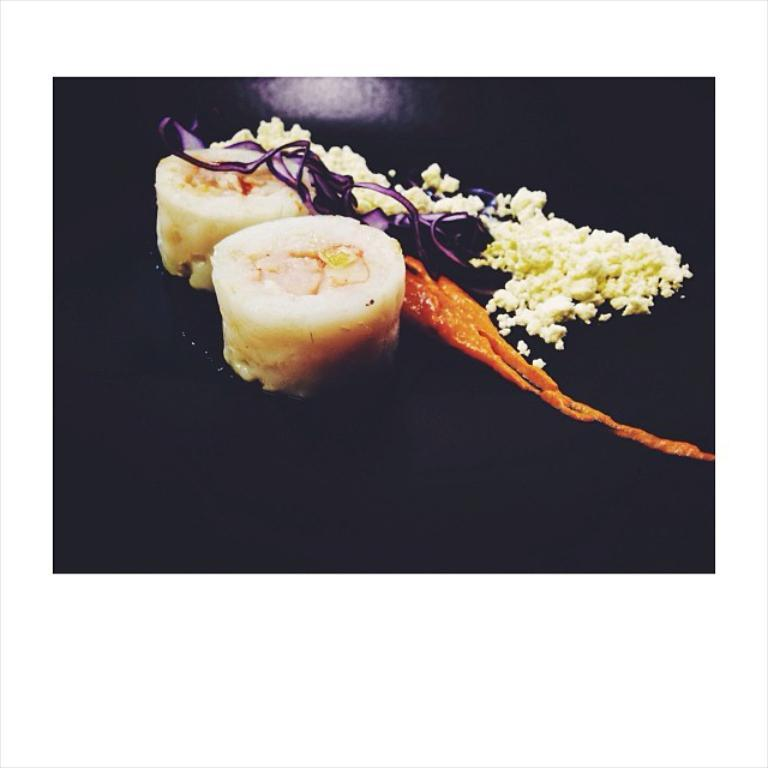What types of items can be seen in the image? There are food items in the image. Can you describe the appearance of the image's edges? The corners of the image are black. How many cherries are on top of the food items in the image? There are no cherries present in the image. What type of expansion is occurring in the image? There is no expansion occurring in the image; it is a static image of food items. 